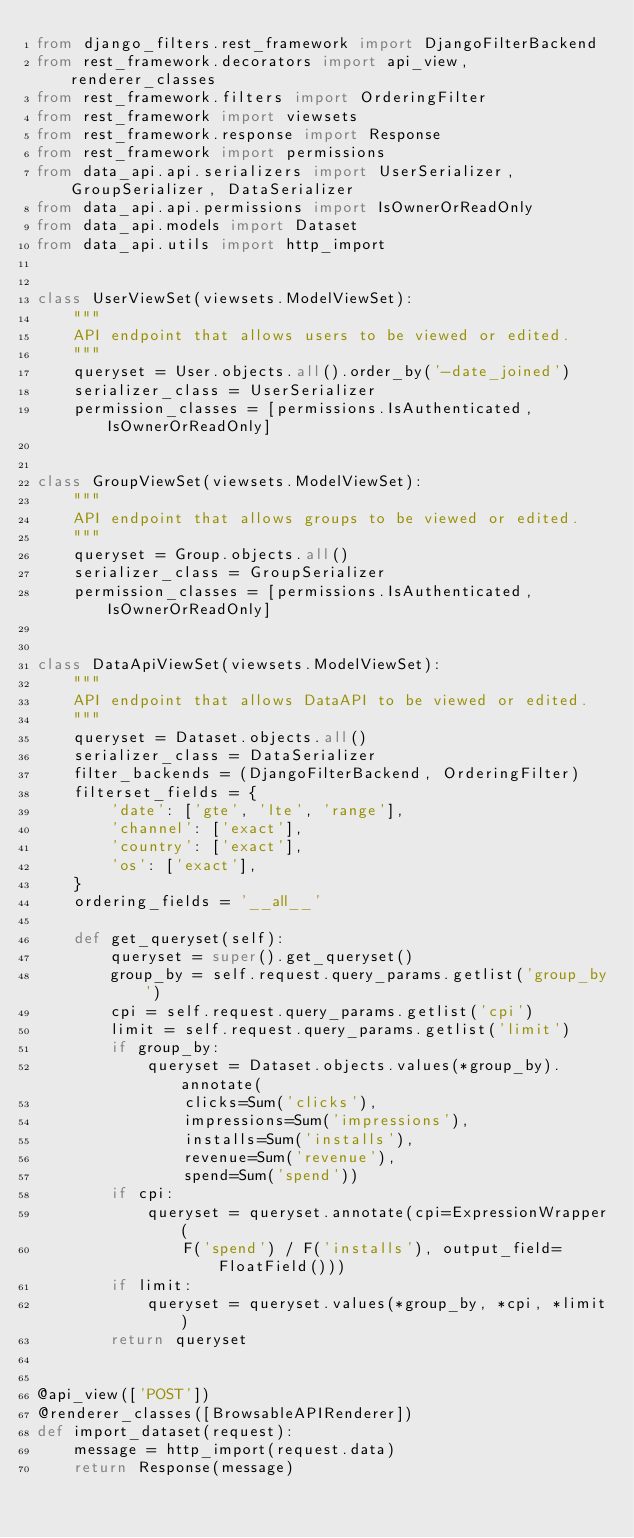<code> <loc_0><loc_0><loc_500><loc_500><_Python_>from django_filters.rest_framework import DjangoFilterBackend
from rest_framework.decorators import api_view, renderer_classes
from rest_framework.filters import OrderingFilter
from rest_framework import viewsets
from rest_framework.response import Response
from rest_framework import permissions
from data_api.api.serializers import UserSerializer, GroupSerializer, DataSerializer
from data_api.api.permissions import IsOwnerOrReadOnly
from data_api.models import Dataset
from data_api.utils import http_import


class UserViewSet(viewsets.ModelViewSet):
    """
    API endpoint that allows users to be viewed or edited.
    """
    queryset = User.objects.all().order_by('-date_joined')
    serializer_class = UserSerializer
    permission_classes = [permissions.IsAuthenticated, IsOwnerOrReadOnly]


class GroupViewSet(viewsets.ModelViewSet):
    """
    API endpoint that allows groups to be viewed or edited.
    """
    queryset = Group.objects.all()
    serializer_class = GroupSerializer
    permission_classes = [permissions.IsAuthenticated, IsOwnerOrReadOnly]


class DataApiViewSet(viewsets.ModelViewSet):
    """
    API endpoint that allows DataAPI to be viewed or edited.
    """
    queryset = Dataset.objects.all()
    serializer_class = DataSerializer
    filter_backends = (DjangoFilterBackend, OrderingFilter)
    filterset_fields = {
        'date': ['gte', 'lte', 'range'],
        'channel': ['exact'],
        'country': ['exact'],
        'os': ['exact'],
    }
    ordering_fields = '__all__'

    def get_queryset(self):
        queryset = super().get_queryset()
        group_by = self.request.query_params.getlist('group_by')
        cpi = self.request.query_params.getlist('cpi')
        limit = self.request.query_params.getlist('limit')
        if group_by:
            queryset = Dataset.objects.values(*group_by).annotate(
                clicks=Sum('clicks'),
                impressions=Sum('impressions'),
                installs=Sum('installs'),
                revenue=Sum('revenue'),
                spend=Sum('spend'))
        if cpi:
            queryset = queryset.annotate(cpi=ExpressionWrapper(
                F('spend') / F('installs'), output_field=FloatField()))
        if limit:
            queryset = queryset.values(*group_by, *cpi, *limit)
        return queryset


@api_view(['POST'])
@renderer_classes([BrowsableAPIRenderer])
def import_dataset(request):
    message = http_import(request.data)
    return Response(message)
</code> 